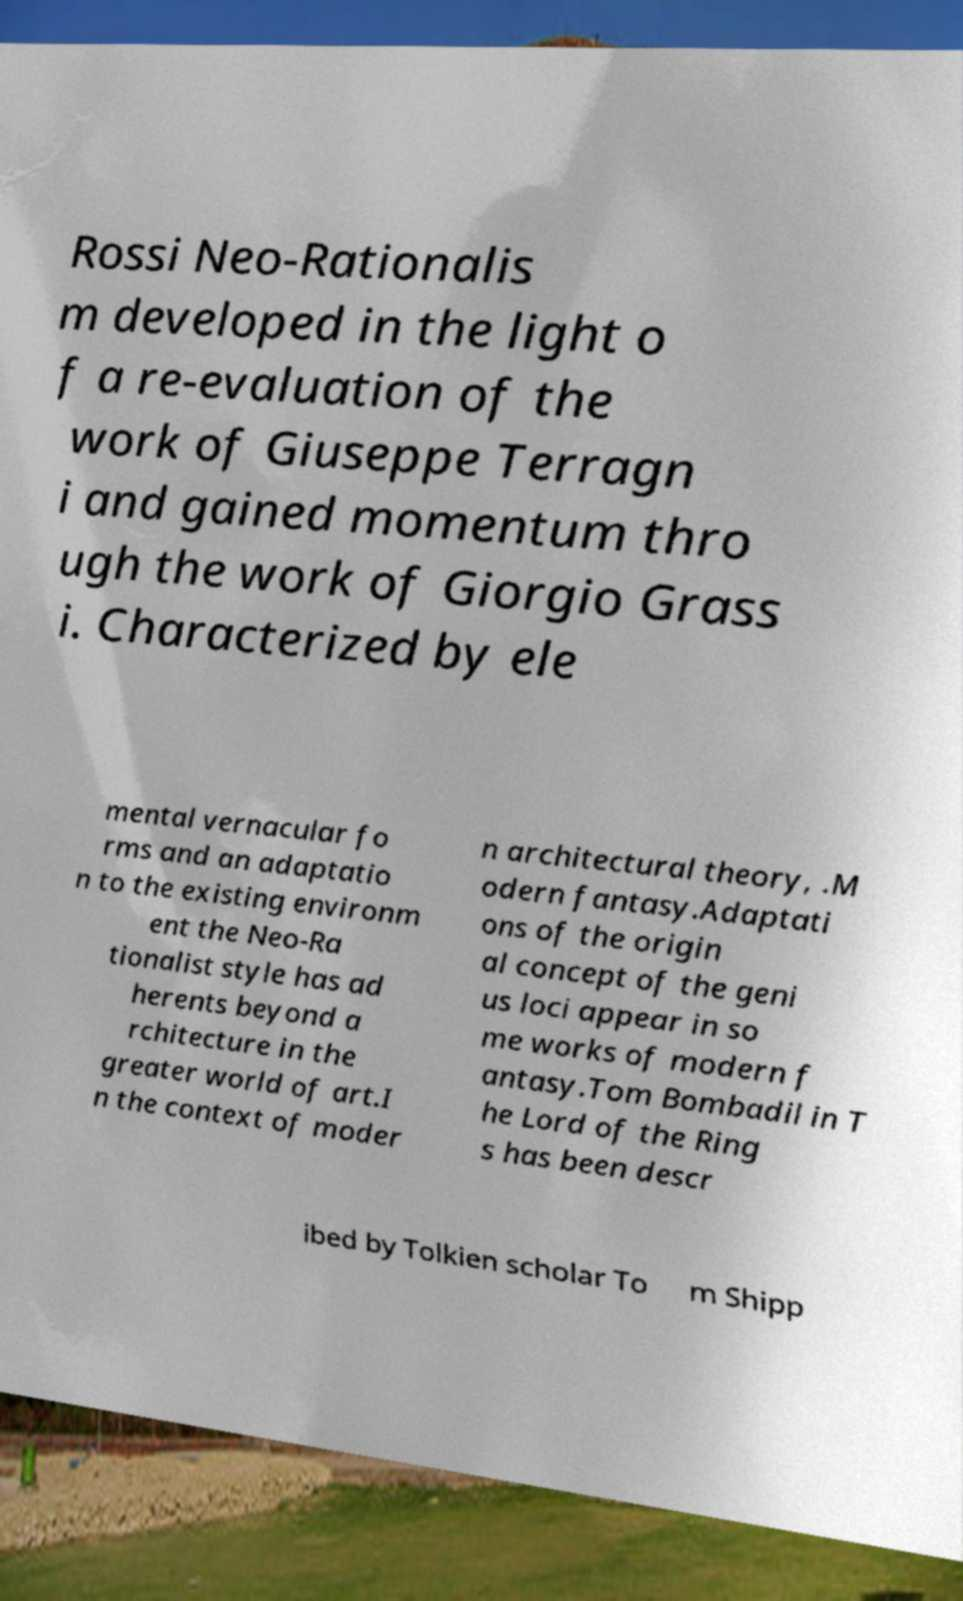Could you assist in decoding the text presented in this image and type it out clearly? Rossi Neo-Rationalis m developed in the light o f a re-evaluation of the work of Giuseppe Terragn i and gained momentum thro ugh the work of Giorgio Grass i. Characterized by ele mental vernacular fo rms and an adaptatio n to the existing environm ent the Neo-Ra tionalist style has ad herents beyond a rchitecture in the greater world of art.I n the context of moder n architectural theory, .M odern fantasy.Adaptati ons of the origin al concept of the geni us loci appear in so me works of modern f antasy.Tom Bombadil in T he Lord of the Ring s has been descr ibed by Tolkien scholar To m Shipp 